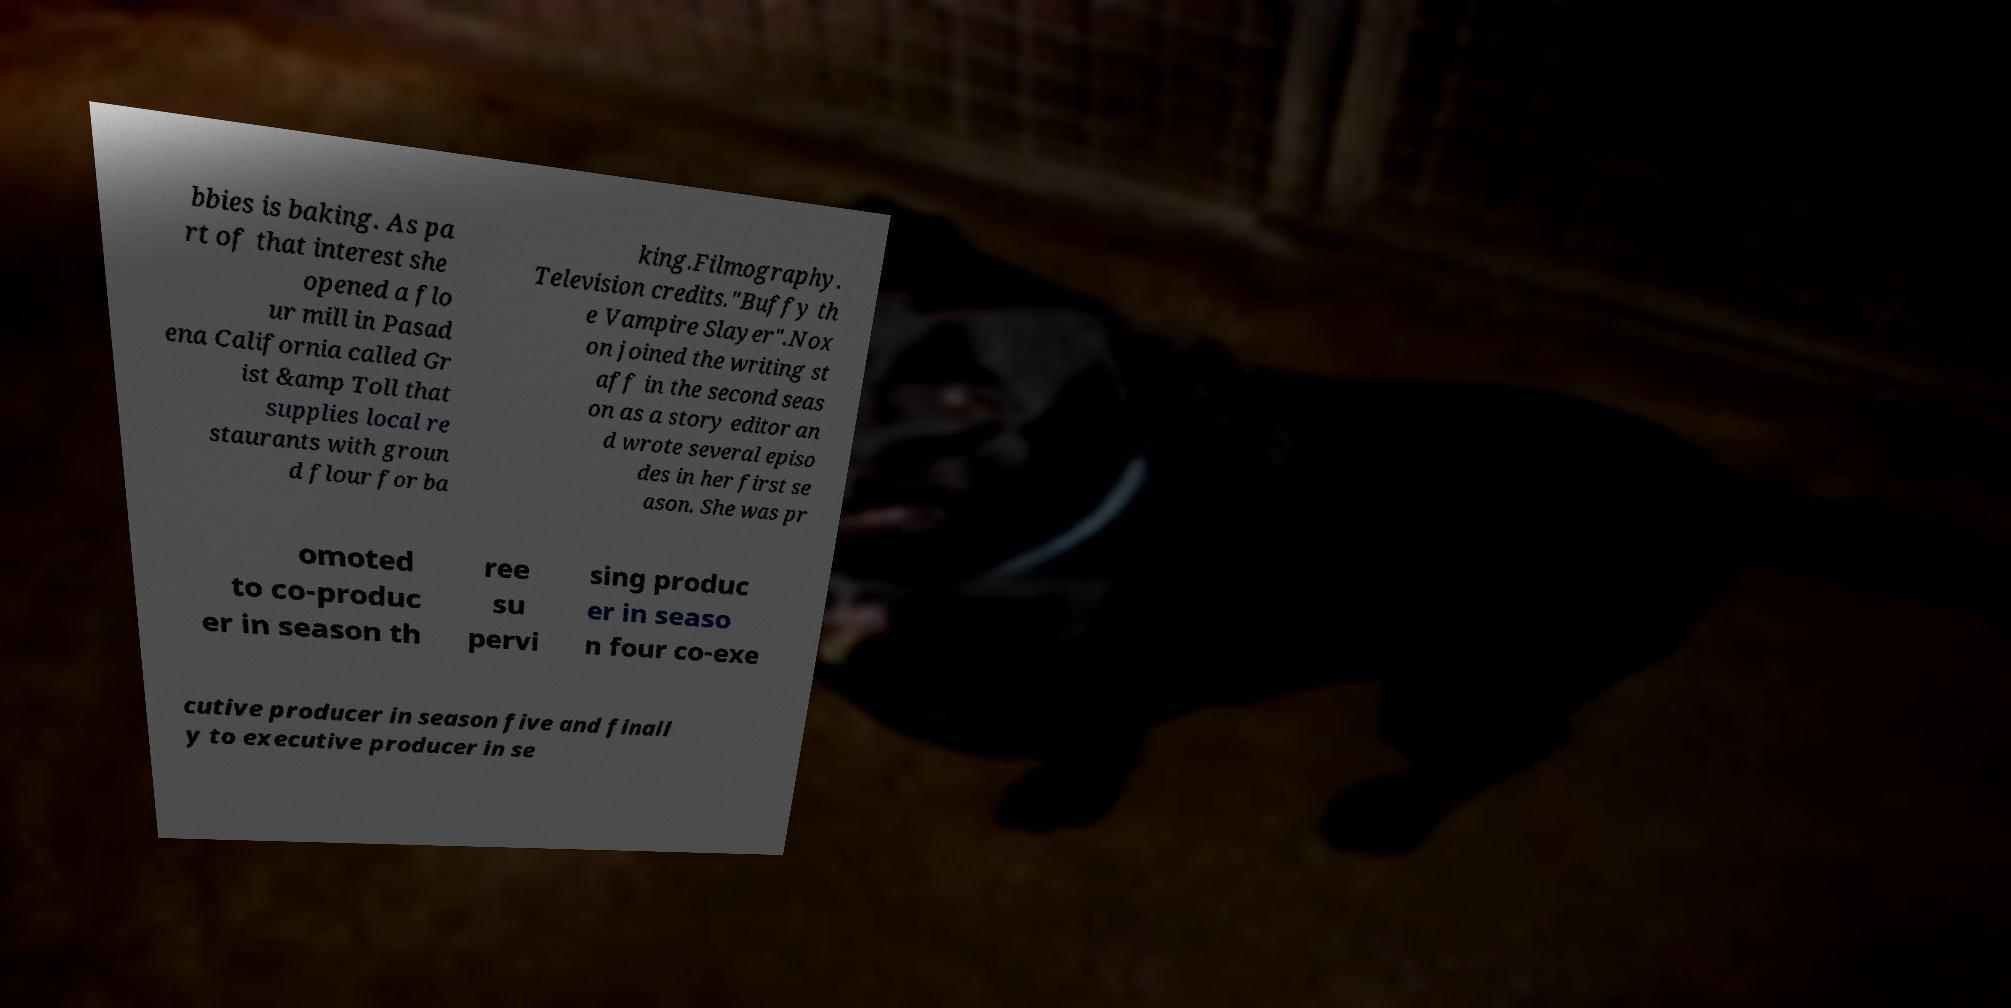What messages or text are displayed in this image? I need them in a readable, typed format. bbies is baking. As pa rt of that interest she opened a flo ur mill in Pasad ena California called Gr ist &amp Toll that supplies local re staurants with groun d flour for ba king.Filmography. Television credits."Buffy th e Vampire Slayer".Nox on joined the writing st aff in the second seas on as a story editor an d wrote several episo des in her first se ason. She was pr omoted to co-produc er in season th ree su pervi sing produc er in seaso n four co-exe cutive producer in season five and finall y to executive producer in se 